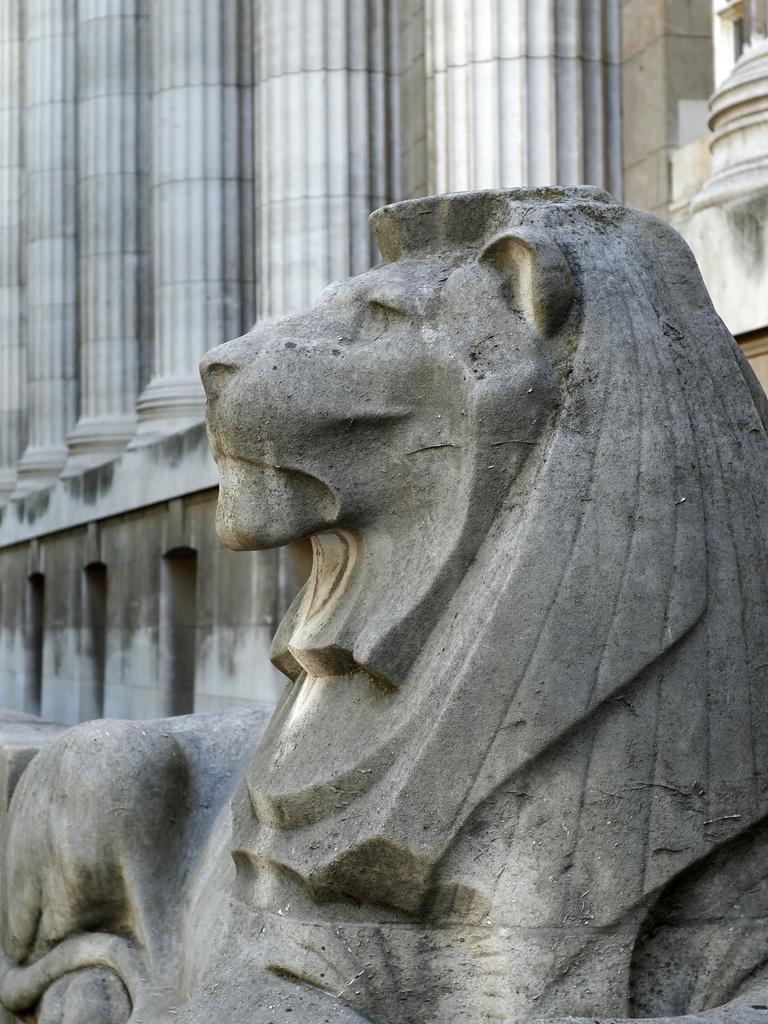Describe this image in one or two sentences. In this picture we can see the statue of an animal, we can see the ground, and the wall with pillars. 